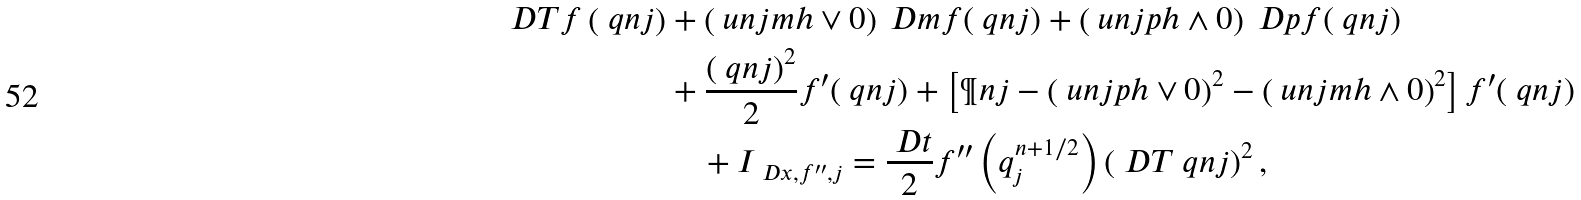Convert formula to latex. <formula><loc_0><loc_0><loc_500><loc_500>\ D T f \left ( \ q n j \right ) & + \left ( \ u n j m h \vee 0 \right ) \ D m f ( \ q n j ) + \left ( \ u n j p h \wedge 0 \right ) \ D p f ( \ q n j ) \\ & + \frac { \left ( \ q n j \right ) ^ { 2 } } { 2 } f ^ { \prime } ( \ q n j ) + \left [ \P n j - \left ( \ u n j p h \vee 0 \right ) ^ { 2 } - \left ( \ u n j m h \wedge 0 \right ) ^ { 2 } \right ] f ^ { \prime } ( \ q n j ) \\ & \quad + I _ { \ D x , f ^ { \prime \prime } , j } = \frac { \ D t } { 2 } f ^ { \prime \prime } \left ( q ^ { n + 1 / 2 } _ { j } \right ) \left ( \ D T \ q n j \right ) ^ { 2 } ,</formula> 